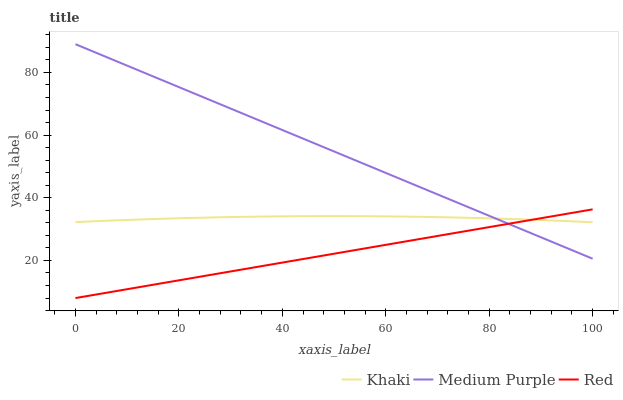Does Red have the minimum area under the curve?
Answer yes or no. Yes. Does Medium Purple have the maximum area under the curve?
Answer yes or no. Yes. Does Khaki have the minimum area under the curve?
Answer yes or no. No. Does Khaki have the maximum area under the curve?
Answer yes or no. No. Is Red the smoothest?
Answer yes or no. Yes. Is Khaki the roughest?
Answer yes or no. Yes. Is Khaki the smoothest?
Answer yes or no. No. Is Red the roughest?
Answer yes or no. No. Does Red have the lowest value?
Answer yes or no. Yes. Does Khaki have the lowest value?
Answer yes or no. No. Does Medium Purple have the highest value?
Answer yes or no. Yes. Does Red have the highest value?
Answer yes or no. No. Does Medium Purple intersect Khaki?
Answer yes or no. Yes. Is Medium Purple less than Khaki?
Answer yes or no. No. Is Medium Purple greater than Khaki?
Answer yes or no. No. 